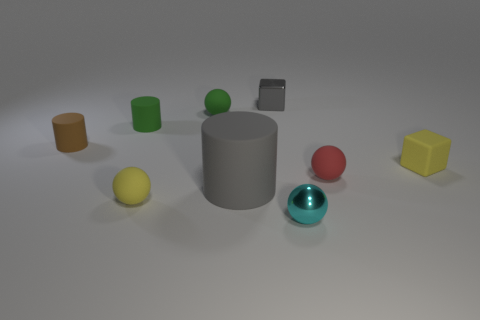There is another tiny thing that is the same shape as the gray shiny thing; what material is it?
Ensure brevity in your answer.  Rubber. Are there any tiny gray rubber things?
Ensure brevity in your answer.  No. What shape is the gray object that is the same material as the yellow block?
Provide a short and direct response. Cylinder. What material is the yellow thing to the right of the big matte object?
Offer a terse response. Rubber. There is a rubber cylinder to the left of the green cylinder; is its color the same as the small matte cube?
Give a very brief answer. No. There is a gray object behind the yellow thing that is behind the big cylinder; how big is it?
Your answer should be very brief. Small. Is the number of small rubber things in front of the small cyan thing greater than the number of big rubber cylinders?
Offer a very short reply. No. Is the size of the metal thing to the left of the cyan ball the same as the large gray rubber object?
Keep it short and to the point. No. The tiny thing that is behind the small green rubber cylinder and in front of the small gray metallic cube is what color?
Give a very brief answer. Green. What shape is the red matte object that is the same size as the brown thing?
Give a very brief answer. Sphere. 